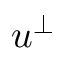Convert formula to latex. <formula><loc_0><loc_0><loc_500><loc_500>u ^ { \perp }</formula> 